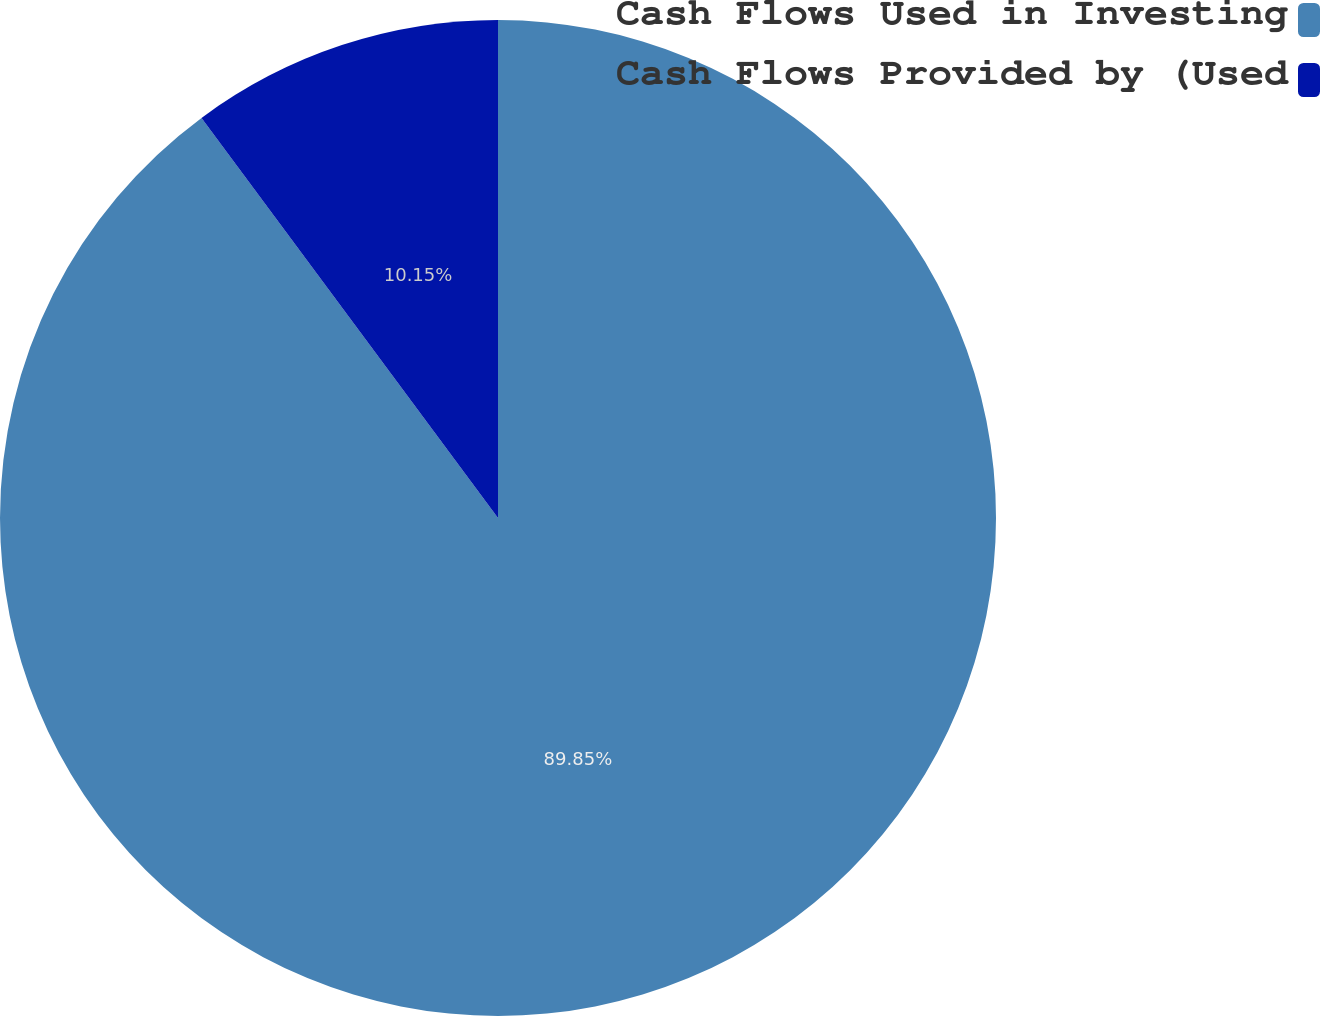Convert chart. <chart><loc_0><loc_0><loc_500><loc_500><pie_chart><fcel>Cash Flows Used in Investing<fcel>Cash Flows Provided by (Used<nl><fcel>89.85%<fcel>10.15%<nl></chart> 